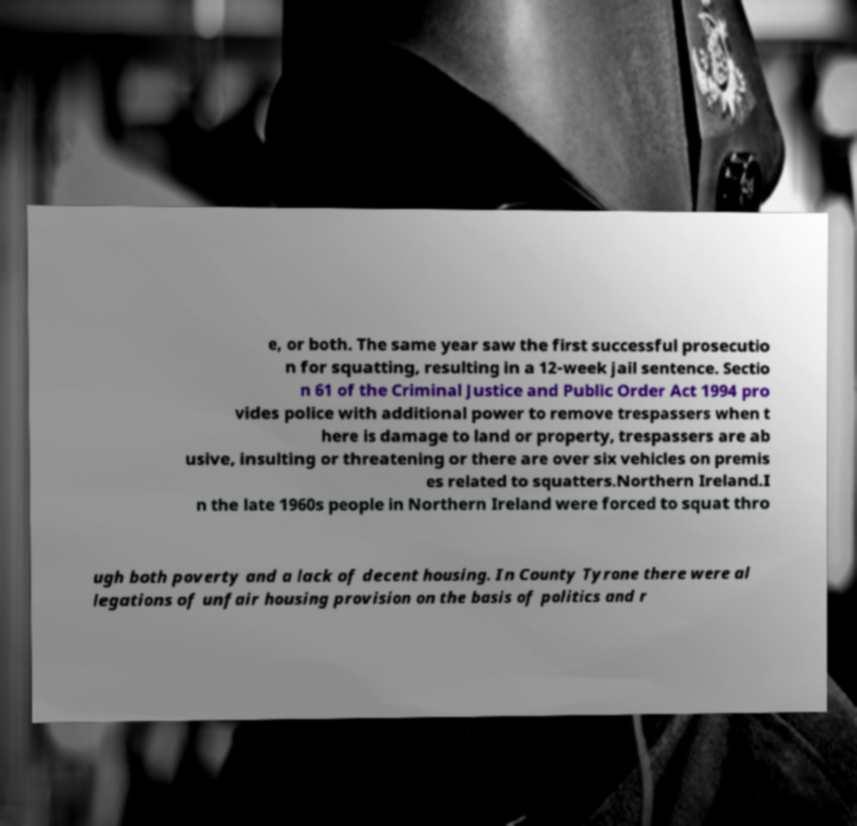Please read and relay the text visible in this image. What does it say? e, or both. The same year saw the first successful prosecutio n for squatting, resulting in a 12-week jail sentence. Sectio n 61 of the Criminal Justice and Public Order Act 1994 pro vides police with additional power to remove trespassers when t here is damage to land or property, trespassers are ab usive, insulting or threatening or there are over six vehicles on premis es related to squatters.Northern Ireland.I n the late 1960s people in Northern Ireland were forced to squat thro ugh both poverty and a lack of decent housing. In County Tyrone there were al legations of unfair housing provision on the basis of politics and r 